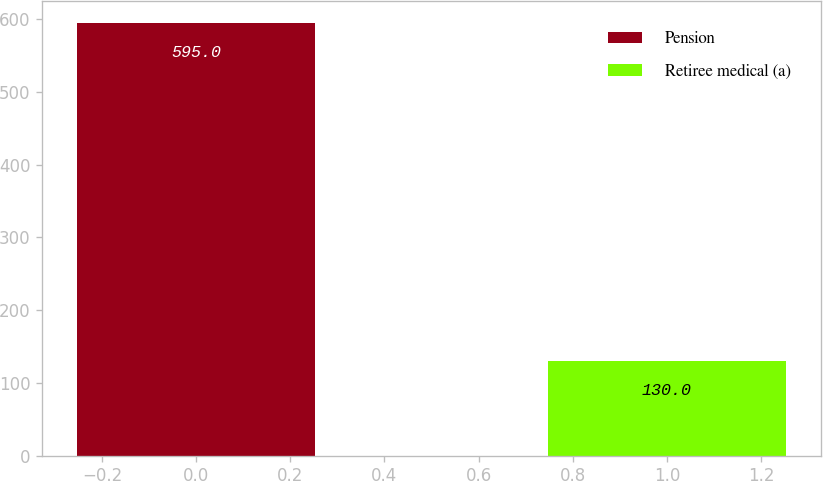<chart> <loc_0><loc_0><loc_500><loc_500><bar_chart><fcel>Pension<fcel>Retiree medical (a)<nl><fcel>595<fcel>130<nl></chart> 